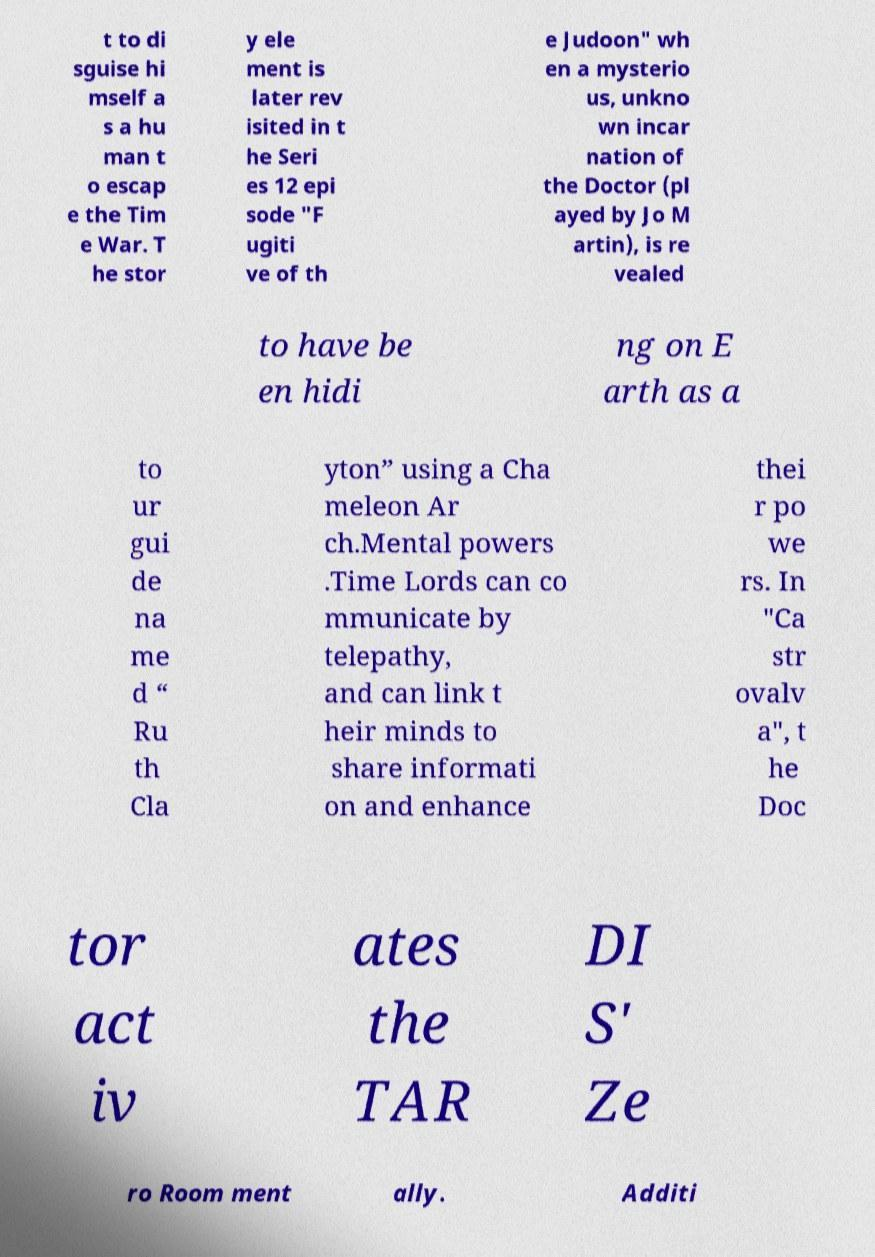Please read and relay the text visible in this image. What does it say? t to di sguise hi mself a s a hu man t o escap e the Tim e War. T he stor y ele ment is later rev isited in t he Seri es 12 epi sode "F ugiti ve of th e Judoon" wh en a mysterio us, unkno wn incar nation of the Doctor (pl ayed by Jo M artin), is re vealed to have be en hidi ng on E arth as a to ur gui de na me d “ Ru th Cla yton” using a Cha meleon Ar ch.Mental powers .Time Lords can co mmunicate by telepathy, and can link t heir minds to share informati on and enhance thei r po we rs. In "Ca str ovalv a", t he Doc tor act iv ates the TAR DI S' Ze ro Room ment ally. Additi 